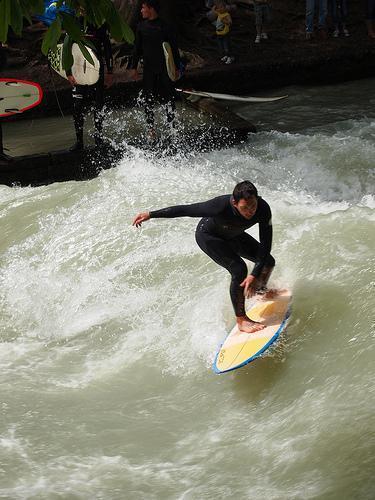How many people are holding surfboards?
Give a very brief answer. 3. 